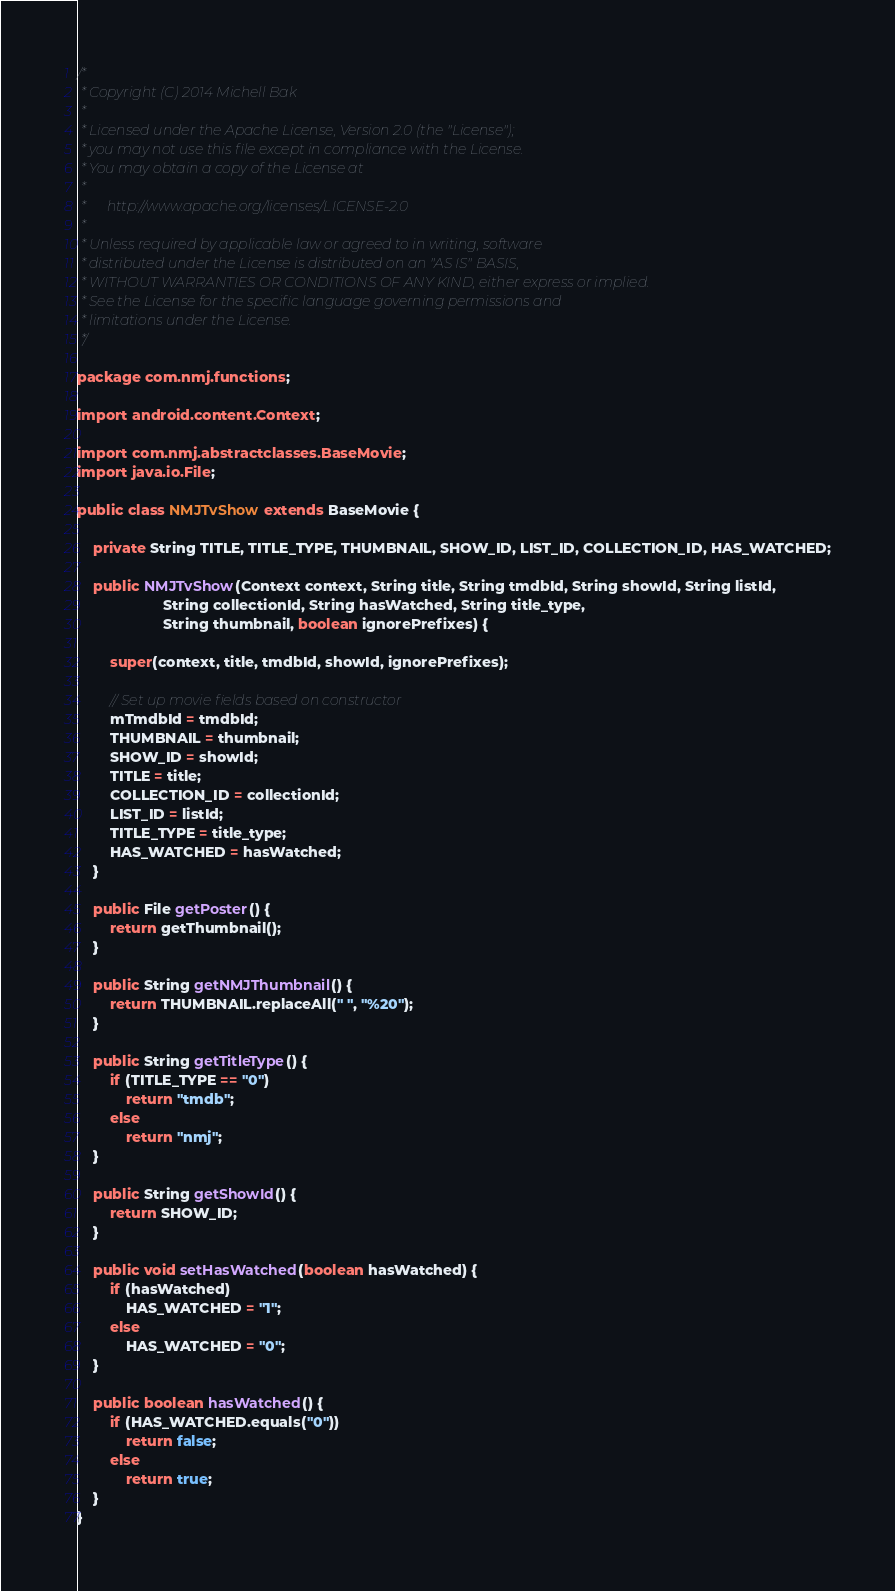Convert code to text. <code><loc_0><loc_0><loc_500><loc_500><_Java_>/*
 * Copyright (C) 2014 Michell Bak
 *
 * Licensed under the Apache License, Version 2.0 (the "License");
 * you may not use this file except in compliance with the License.
 * You may obtain a copy of the License at
 *
 *      http://www.apache.org/licenses/LICENSE-2.0
 *
 * Unless required by applicable law or agreed to in writing, software
 * distributed under the License is distributed on an "AS IS" BASIS,
 * WITHOUT WARRANTIES OR CONDITIONS OF ANY KIND, either express or implied.
 * See the License for the specific language governing permissions and
 * limitations under the License.
 */

package com.nmj.functions;

import android.content.Context;

import com.nmj.abstractclasses.BaseMovie;
import java.io.File;

public class NMJTvShow extends BaseMovie {

    private String TITLE, TITLE_TYPE, THUMBNAIL, SHOW_ID, LIST_ID, COLLECTION_ID, HAS_WATCHED;

    public NMJTvShow(Context context, String title, String tmdbId, String showId, String listId,
                     String collectionId, String hasWatched, String title_type,
                     String thumbnail, boolean ignorePrefixes) {

        super(context, title, tmdbId, showId, ignorePrefixes);

        // Set up movie fields based on constructor
        mTmdbId = tmdbId;
        THUMBNAIL = thumbnail;
        SHOW_ID = showId;
        TITLE = title;
        COLLECTION_ID = collectionId;
        LIST_ID = listId;
        TITLE_TYPE = title_type;
        HAS_WATCHED = hasWatched;
    }

    public File getPoster() {
        return getThumbnail();
    }

    public String getNMJThumbnail() {
        return THUMBNAIL.replaceAll(" ", "%20");
    }

    public String getTitleType() {
        if (TITLE_TYPE == "0")
            return "tmdb";
        else
            return "nmj";
    }

    public String getShowId() {
        return SHOW_ID;
    }

    public void setHasWatched(boolean hasWatched) {
        if (hasWatched)
            HAS_WATCHED = "1";
        else
            HAS_WATCHED = "0";
    }

    public boolean hasWatched() {
        if (HAS_WATCHED.equals("0"))
            return false;
        else
            return true;
    }
}</code> 